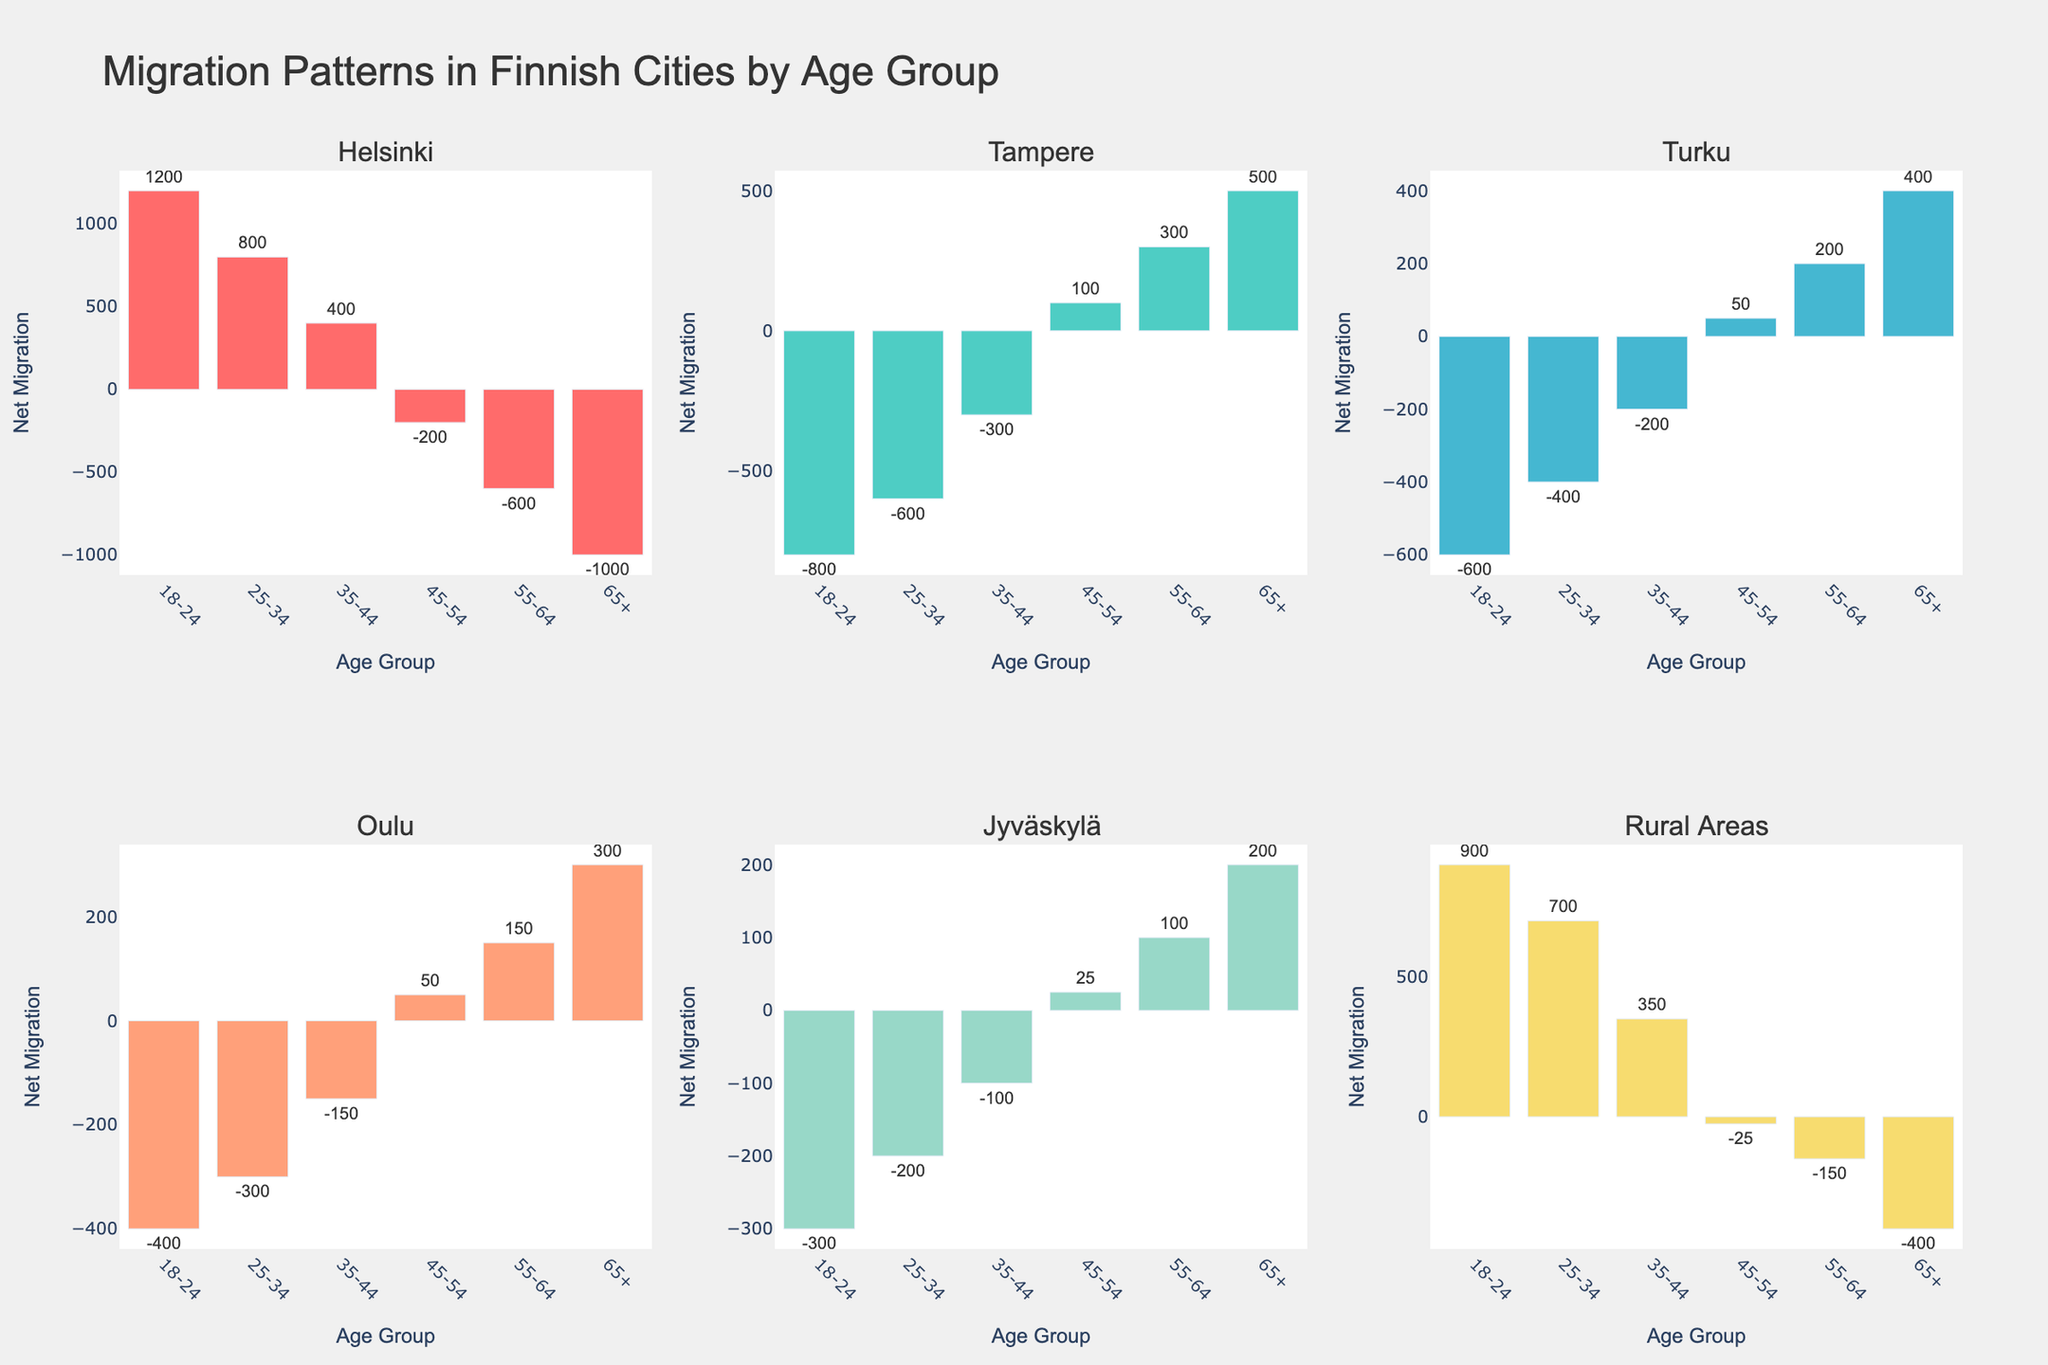What city has the highest net migration for the age group 65+? The net migration for the age group 65+ is highest in the city where the bar extends the most above the zero line. This city is Tampere with a net migration of 500.
Answer: Tampere Which age group in Oulu has a positive net migration? The bar for the 45-54 age group in Oulu is above zero, indicating a positive net migration of 50.
Answer: 45-54 How does the net migration of Helsinki for the 25-34 age group compare to that of Jyväskylä? By comparing the height of the bars for the 25-34 age group in Helsinki and Jyväskylä, Helsinki has a net migration of 800 while Jyväskylä has -200.
Answer: Helsinki has a higher net migration What is the sum of net migration for all age groups in Rural Areas? Sum of net migrations for Rural Areas: 900 + 700 + 350 - 25 - 150 - 400 = 1375
Answer: 1375 Which city's net migration for the 18-24 age group is closest to zero? For the 18-24 age group, Jyväskylä has the net migration closest to zero at -300.
Answer: Jyväskylä Which age group has the largest decrease in net migration between the age group 45-54 and 55-64 in Helsinki? The decrease in net migration from 45-54 to 55-64 in Helsinki is from -200 to -600, a decrease of -400.
Answer: The age group 55-64 Are there any cities that have negative net migration for the age groups 18-24 and 25-34? Both Tampere and Turku have negative net migration for the age groups 18-24 (-800, -600) and 25-34 (-600, -400).
Answer: Tampere and Turku What is the average net migration in Turku across all age groups? The total net migration for Turku across all age groups is: -600 - 400 - 200 + 50 + 200 + 400 = -550. Average is -550/6 = -91.67.
Answer: -91.67 Which age group shows the highest positive net migration in Jyväskylä? The age group with the highest positive net migration in Jyväskylä is 65+ with a net migration of 200.
Answer: 65+ Does any city have a positive net migration for the age group 45-54, except Rural Areas? Yes, Tampere, Turku, Oulu, and Jyväskylä have positive net migration for the age group 45-54.
Answer: Tampere, Turku, Oulu, and Jyväskylä 